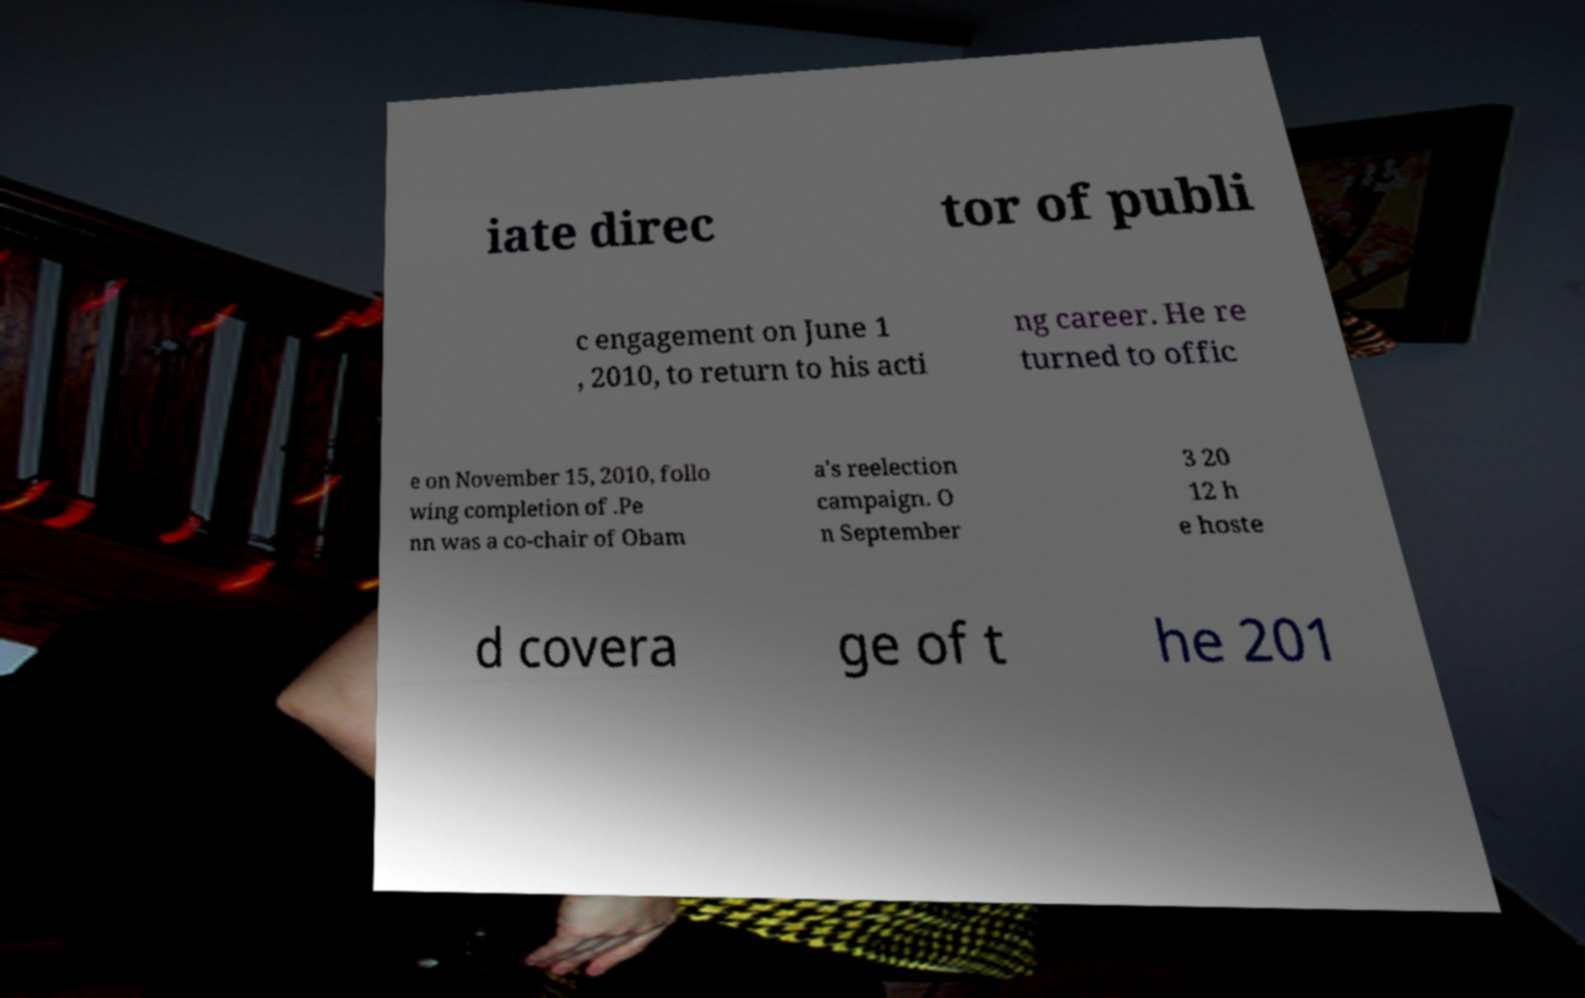What messages or text are displayed in this image? I need them in a readable, typed format. iate direc tor of publi c engagement on June 1 , 2010, to return to his acti ng career. He re turned to offic e on November 15, 2010, follo wing completion of .Pe nn was a co-chair of Obam a's reelection campaign. O n September 3 20 12 h e hoste d covera ge of t he 201 